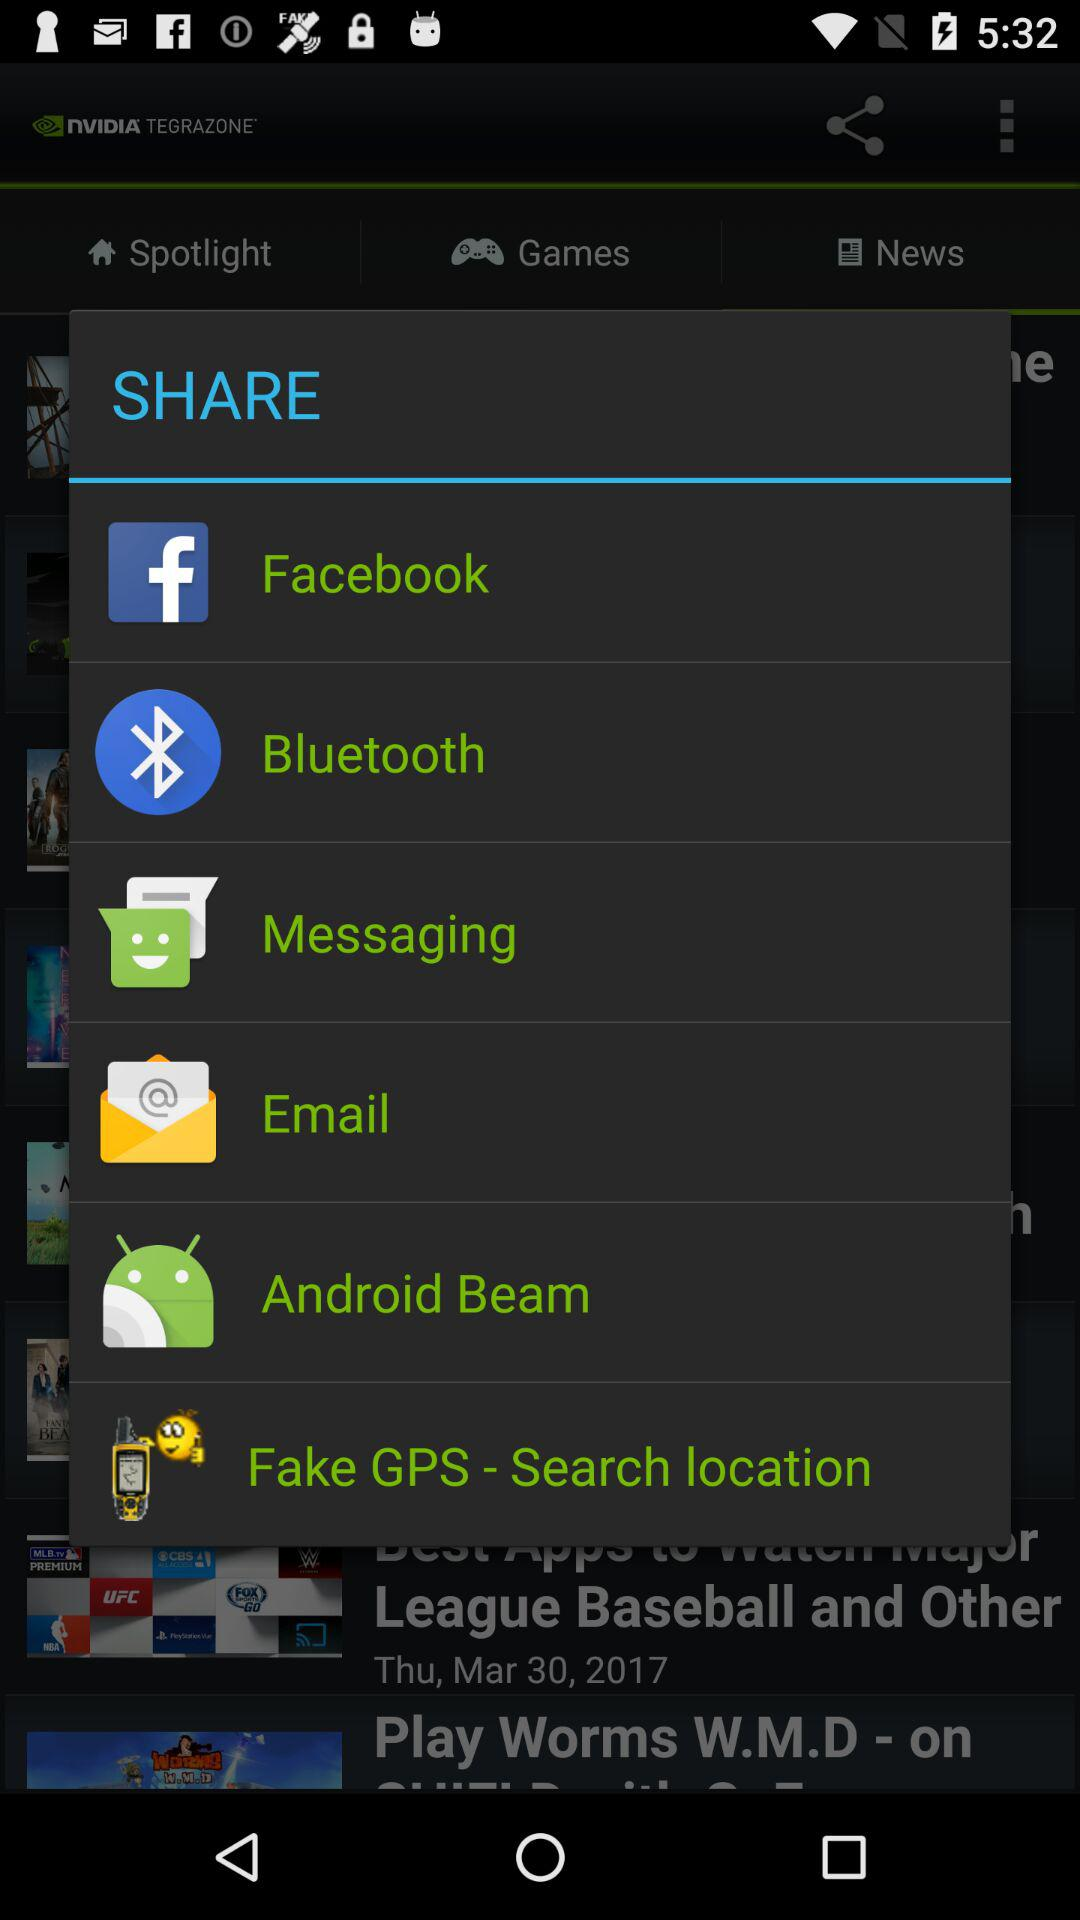When was the post "Play Worms W.M.D" posted?
When the provided information is insufficient, respond with <no answer>. <no answer> 